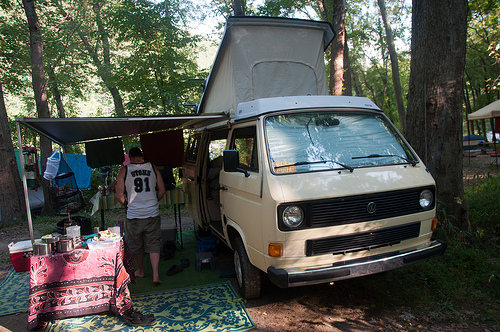<image>
Is the tire under the man? No. The tire is not positioned under the man. The vertical relationship between these objects is different. Is there a rug next to the van? Yes. The rug is positioned adjacent to the van, located nearby in the same general area. 